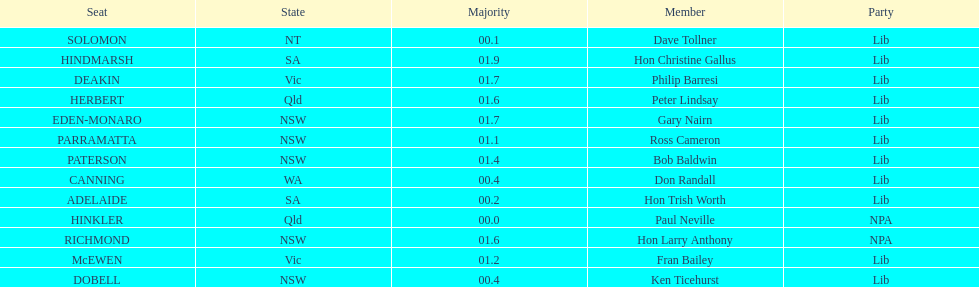Would you mind parsing the complete table? {'header': ['Seat', 'State', 'Majority', 'Member', 'Party'], 'rows': [['SOLOMON', 'NT', '00.1', 'Dave Tollner', 'Lib'], ['HINDMARSH', 'SA', '01.9', 'Hon Christine Gallus', 'Lib'], ['DEAKIN', 'Vic', '01.7', 'Philip Barresi', 'Lib'], ['HERBERT', 'Qld', '01.6', 'Peter Lindsay', 'Lib'], ['EDEN-MONARO', 'NSW', '01.7', 'Gary Nairn', 'Lib'], ['PARRAMATTA', 'NSW', '01.1', 'Ross Cameron', 'Lib'], ['PATERSON', 'NSW', '01.4', 'Bob Baldwin', 'Lib'], ['CANNING', 'WA', '00.4', 'Don Randall', 'Lib'], ['ADELAIDE', 'SA', '00.2', 'Hon Trish Worth', 'Lib'], ['HINKLER', 'Qld', '00.0', 'Paul Neville', 'NPA'], ['RICHMOND', 'NSW', '01.6', 'Hon Larry Anthony', 'NPA'], ['McEWEN', 'Vic', '01.2', 'Fran Bailey', 'Lib'], ['DOBELL', 'NSW', '00.4', 'Ken Ticehurst', 'Lib']]} What member comes next after hon trish worth? Don Randall. 